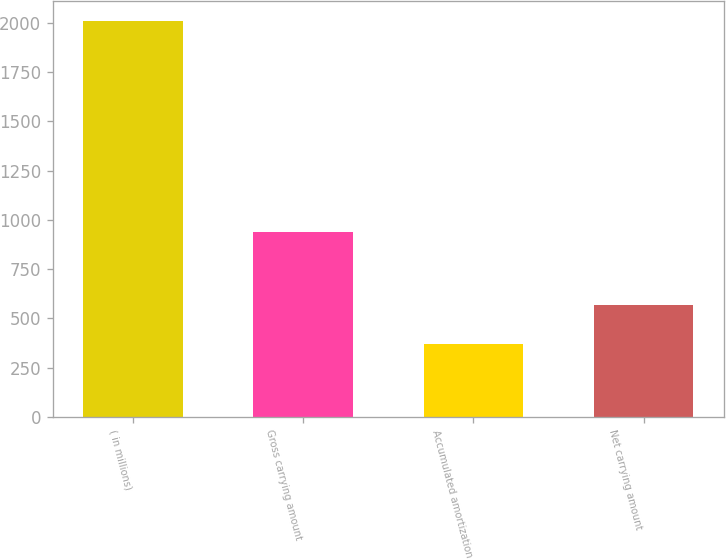Convert chart to OTSL. <chart><loc_0><loc_0><loc_500><loc_500><bar_chart><fcel>( in millions)<fcel>Gross carrying amount<fcel>Accumulated amortization<fcel>Net carrying amount<nl><fcel>2011<fcel>939<fcel>372<fcel>567<nl></chart> 